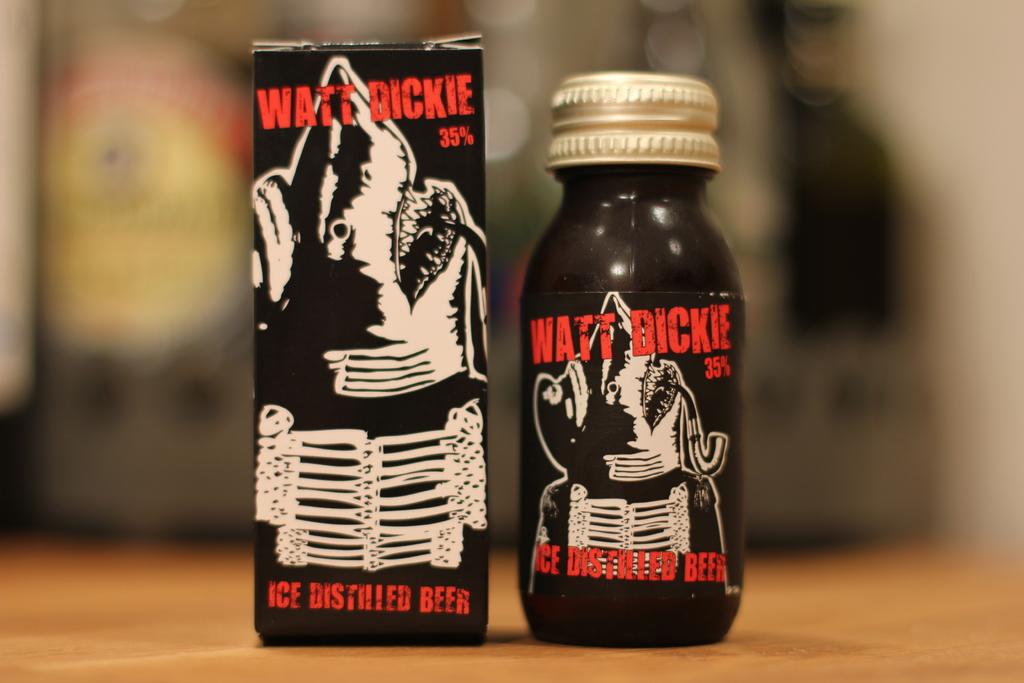What variety of beer is this?
Make the answer very short. Watt dickie. 